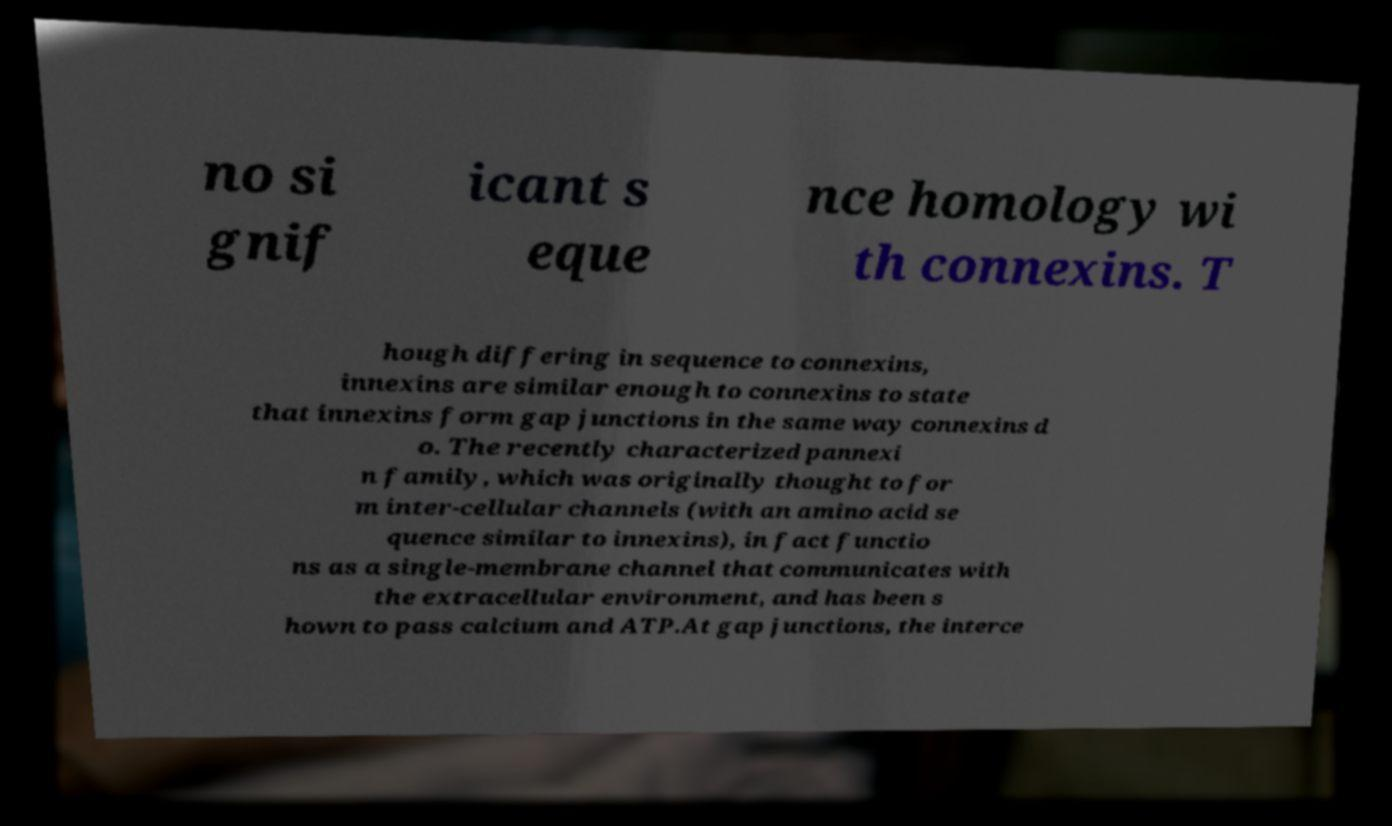Can you accurately transcribe the text from the provided image for me? no si gnif icant s eque nce homology wi th connexins. T hough differing in sequence to connexins, innexins are similar enough to connexins to state that innexins form gap junctions in the same way connexins d o. The recently characterized pannexi n family, which was originally thought to for m inter-cellular channels (with an amino acid se quence similar to innexins), in fact functio ns as a single-membrane channel that communicates with the extracellular environment, and has been s hown to pass calcium and ATP.At gap junctions, the interce 